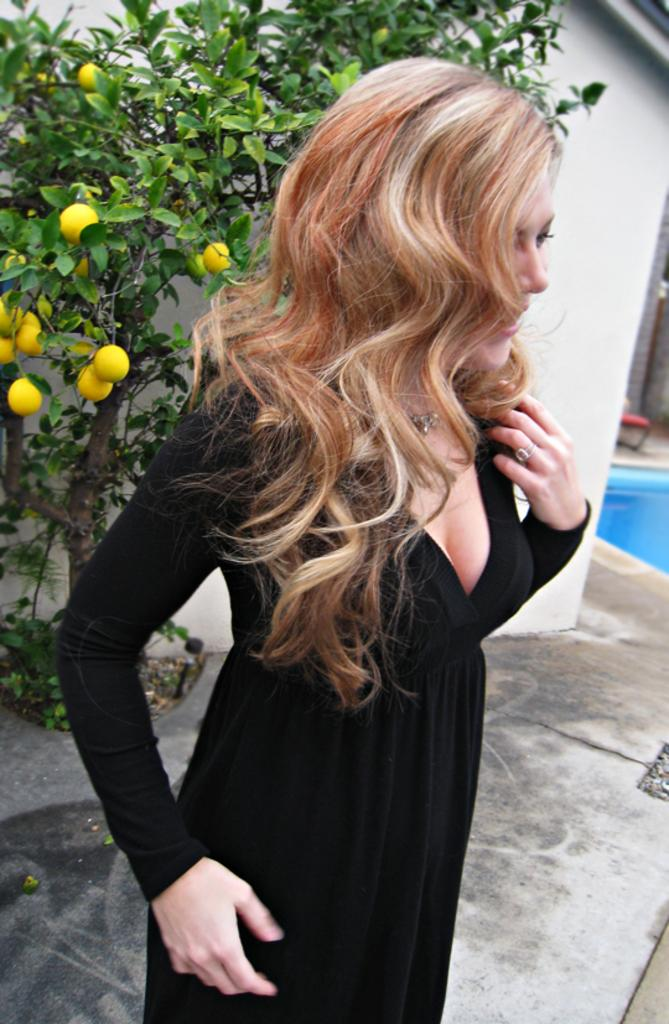What is the main subject of the image? There is a woman standing in the middle of the image. What can be seen behind the woman? There is a lemon tree visible behind the woman. Are there any fruits on the tree? Yes, lemons are present on the tree. What is visible behind the lemon tree? There is a wall visible behind the tree. What type of summer system is being used to irrigate the lemon tree in the image? There is no irrigation system visible in the image, and the concept of a "summer system" is not relevant to the image. 